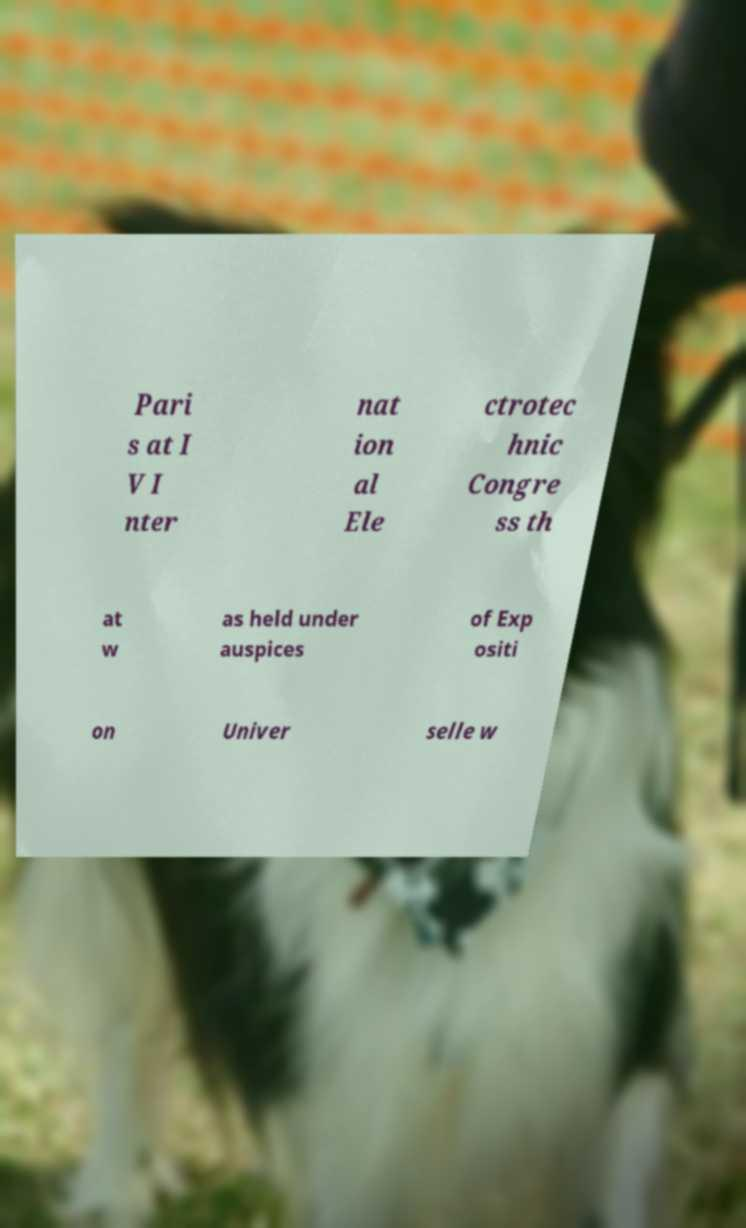I need the written content from this picture converted into text. Can you do that? Pari s at I V I nter nat ion al Ele ctrotec hnic Congre ss th at w as held under auspices of Exp ositi on Univer selle w 